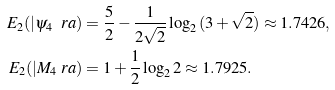<formula> <loc_0><loc_0><loc_500><loc_500>E _ { 2 } ( | \psi _ { 4 } \ r a ) & = \frac { 5 } { 2 } - \frac { 1 } { 2 \sqrt { 2 } } \log _ { 2 } { ( 3 + \sqrt { 2 } ) } \approx 1 . 7 4 2 6 , \\ E _ { 2 } ( | M _ { 4 } \ r a ) & = 1 + \frac { 1 } { 2 } \log _ { 2 } { 2 } \approx 1 . 7 9 2 5 .</formula> 